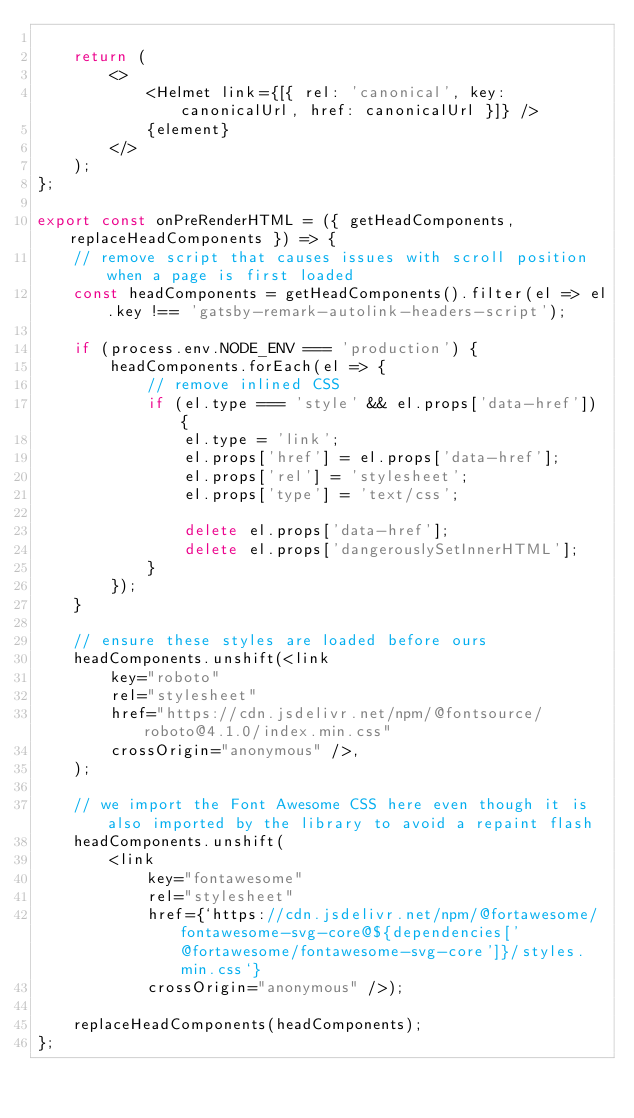<code> <loc_0><loc_0><loc_500><loc_500><_JavaScript_>
    return (
        <>
            <Helmet link={[{ rel: 'canonical', key: canonicalUrl, href: canonicalUrl }]} />
            {element}
        </>
    );
};

export const onPreRenderHTML = ({ getHeadComponents, replaceHeadComponents }) => {
    // remove script that causes issues with scroll position when a page is first loaded
    const headComponents = getHeadComponents().filter(el => el.key !== 'gatsby-remark-autolink-headers-script');

    if (process.env.NODE_ENV === 'production') {
        headComponents.forEach(el => {
            // remove inlined CSS
            if (el.type === 'style' && el.props['data-href']) {
                el.type = 'link';
                el.props['href'] = el.props['data-href'];
                el.props['rel'] = 'stylesheet';
                el.props['type'] = 'text/css';

                delete el.props['data-href'];
                delete el.props['dangerouslySetInnerHTML'];
            }
        });
    }

    // ensure these styles are loaded before ours
    headComponents.unshift(<link
        key="roboto"
        rel="stylesheet"
        href="https://cdn.jsdelivr.net/npm/@fontsource/roboto@4.1.0/index.min.css"
        crossOrigin="anonymous" />,
    );

    // we import the Font Awesome CSS here even though it is also imported by the library to avoid a repaint flash
    headComponents.unshift(
        <link
            key="fontawesome"
            rel="stylesheet"
            href={`https://cdn.jsdelivr.net/npm/@fortawesome/fontawesome-svg-core@${dependencies['@fortawesome/fontawesome-svg-core']}/styles.min.css`}
            crossOrigin="anonymous" />);

    replaceHeadComponents(headComponents);
};
</code> 